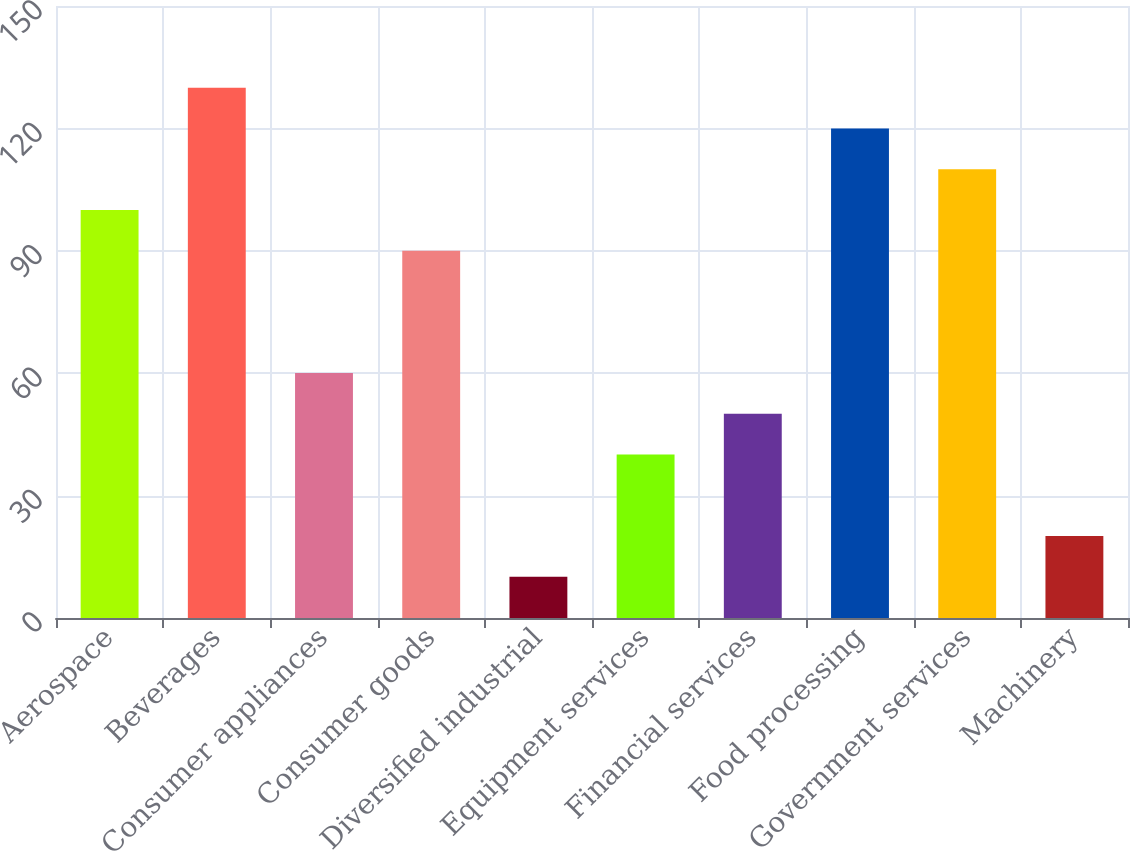Convert chart to OTSL. <chart><loc_0><loc_0><loc_500><loc_500><bar_chart><fcel>Aerospace<fcel>Beverages<fcel>Consumer appliances<fcel>Consumer goods<fcel>Diversified industrial<fcel>Equipment services<fcel>Financial services<fcel>Food processing<fcel>Government services<fcel>Machinery<nl><fcel>100<fcel>129.97<fcel>60.04<fcel>90.01<fcel>10.09<fcel>40.06<fcel>50.05<fcel>119.98<fcel>109.99<fcel>20.08<nl></chart> 